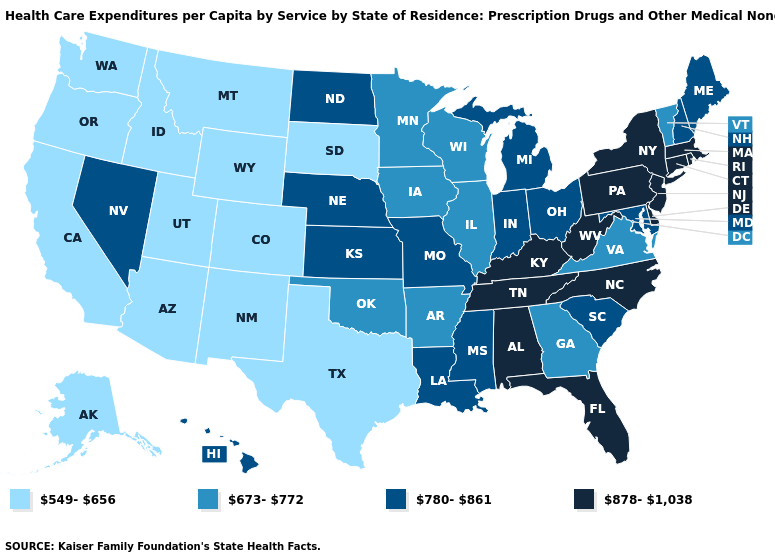Name the states that have a value in the range 780-861?
Answer briefly. Hawaii, Indiana, Kansas, Louisiana, Maine, Maryland, Michigan, Mississippi, Missouri, Nebraska, Nevada, New Hampshire, North Dakota, Ohio, South Carolina. What is the value of Minnesota?
Answer briefly. 673-772. What is the value of New Jersey?
Quick response, please. 878-1,038. What is the highest value in states that border Wisconsin?
Short answer required. 780-861. Name the states that have a value in the range 780-861?
Quick response, please. Hawaii, Indiana, Kansas, Louisiana, Maine, Maryland, Michigan, Mississippi, Missouri, Nebraska, Nevada, New Hampshire, North Dakota, Ohio, South Carolina. Name the states that have a value in the range 673-772?
Keep it brief. Arkansas, Georgia, Illinois, Iowa, Minnesota, Oklahoma, Vermont, Virginia, Wisconsin. What is the value of Nebraska?
Concise answer only. 780-861. What is the value of South Carolina?
Give a very brief answer. 780-861. What is the value of Minnesota?
Give a very brief answer. 673-772. Does South Carolina have the highest value in the USA?
Keep it brief. No. Does Colorado have the highest value in the USA?
Give a very brief answer. No. Among the states that border Ohio , does West Virginia have the highest value?
Keep it brief. Yes. Does Pennsylvania have the same value as North Carolina?
Concise answer only. Yes. What is the value of Minnesota?
Quick response, please. 673-772. Does Montana have the lowest value in the USA?
Keep it brief. Yes. 